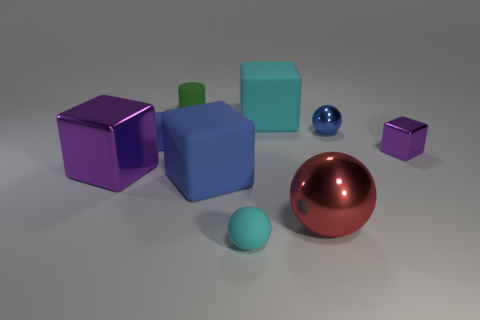Is the number of big purple shiny cubes greater than the number of small balls?
Provide a succinct answer. No. Is the large blue rubber object the same shape as the tiny blue shiny object?
Offer a terse response. No. Is there anything else that is the same shape as the large cyan rubber thing?
Offer a terse response. Yes. Is the color of the metal cube that is to the left of the small green rubber thing the same as the small metallic object that is left of the small purple metallic thing?
Make the answer very short. No. Is the number of tiny purple shiny blocks behind the tiny green cylinder less than the number of small blue cubes in front of the small matte ball?
Offer a terse response. No. The tiny thing that is in front of the large red sphere has what shape?
Provide a short and direct response. Sphere. What is the material of the tiny object that is the same color as the small metal ball?
Your answer should be compact. Rubber. What number of other things are the same material as the tiny purple object?
Keep it short and to the point. 3. Is the shape of the large red metallic thing the same as the large matte object in front of the blue sphere?
Provide a succinct answer. No. What shape is the large purple object that is made of the same material as the big red ball?
Provide a short and direct response. Cube. 